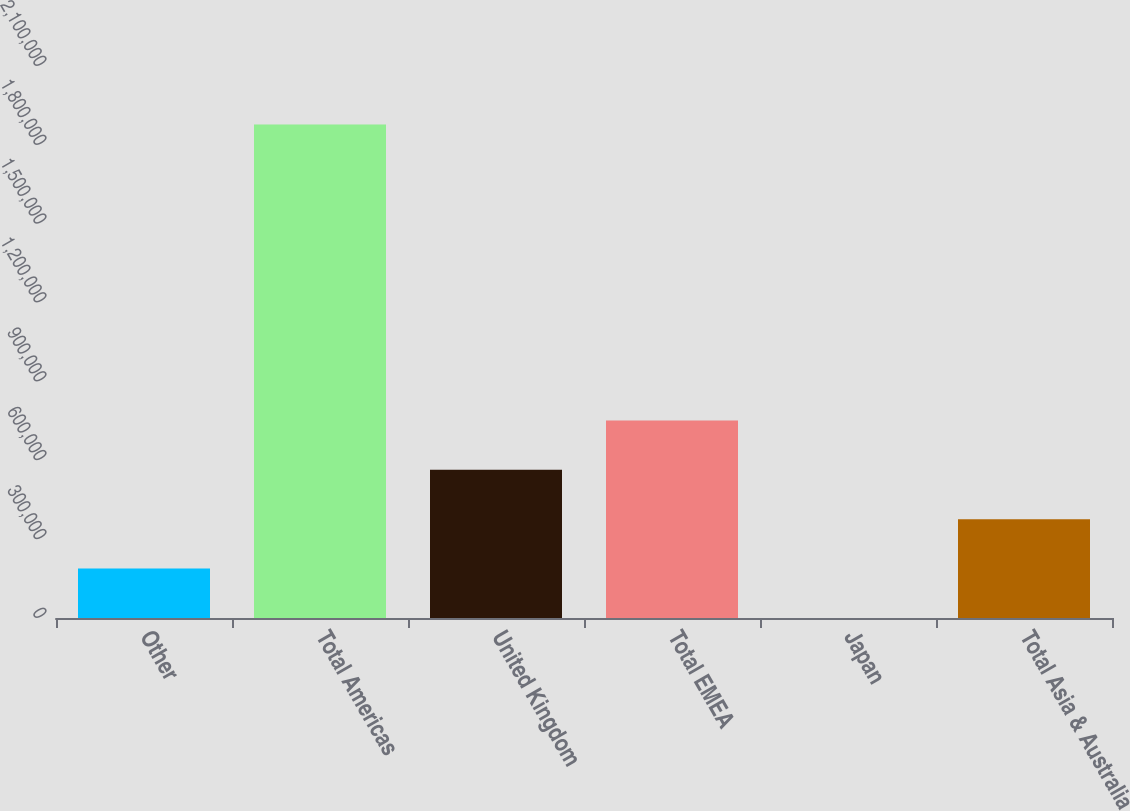Convert chart to OTSL. <chart><loc_0><loc_0><loc_500><loc_500><bar_chart><fcel>Other<fcel>Total Americas<fcel>United Kingdom<fcel>Total EMEA<fcel>Japan<fcel>Total Asia & Australia<nl><fcel>188112<fcel>1.87791e+06<fcel>563623<fcel>751378<fcel>357<fcel>375867<nl></chart> 